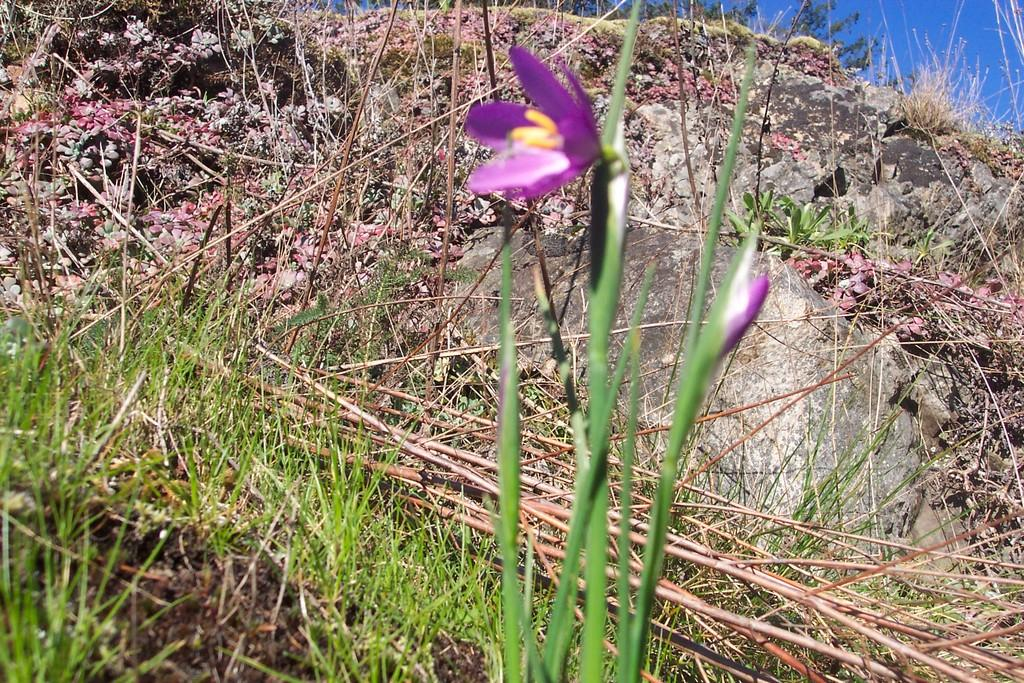Where was the image taken? The image was clicked outside. What can be seen in the foreground of the image? There are plants and grass in the foreground of the image. What is visible in the background of the image? There is a sky visible in the background of the image, along with rocks. What is the opinion of the plants regarding the ongoing protest in the image? There is no protest present in the image, and plants do not have opinions. 